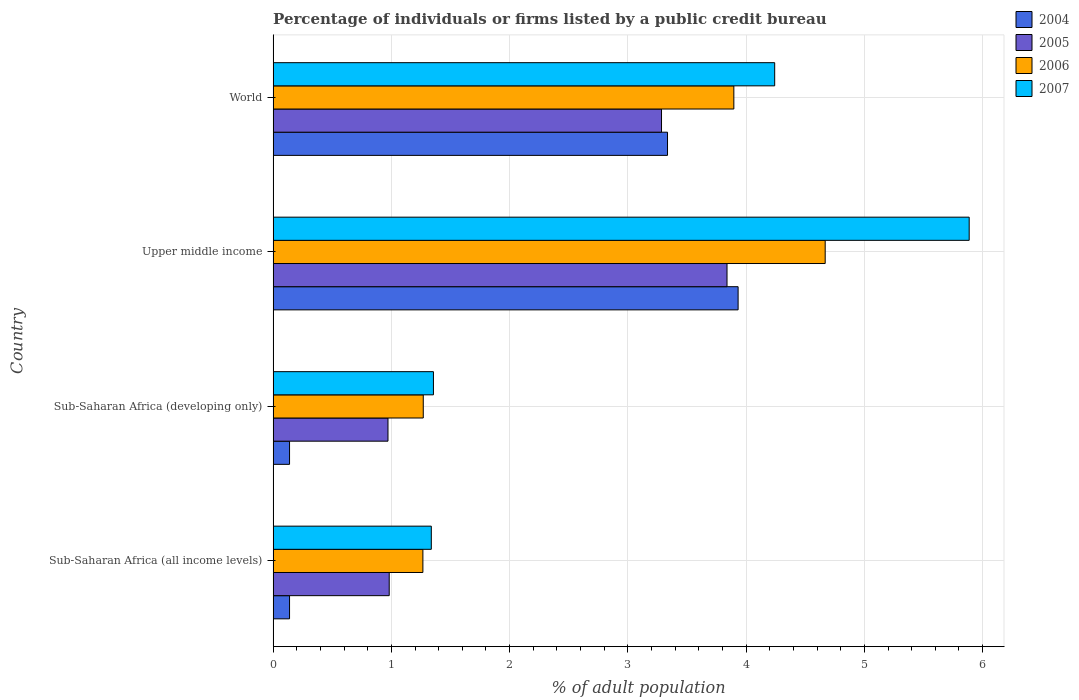How many groups of bars are there?
Provide a short and direct response. 4. Are the number of bars on each tick of the Y-axis equal?
Give a very brief answer. Yes. How many bars are there on the 3rd tick from the top?
Make the answer very short. 4. How many bars are there on the 1st tick from the bottom?
Offer a terse response. 4. What is the label of the 3rd group of bars from the top?
Provide a short and direct response. Sub-Saharan Africa (developing only). In how many cases, is the number of bars for a given country not equal to the number of legend labels?
Offer a terse response. 0. What is the percentage of population listed by a public credit bureau in 2004 in Sub-Saharan Africa (all income levels)?
Your answer should be very brief. 0.14. Across all countries, what is the maximum percentage of population listed by a public credit bureau in 2005?
Your answer should be compact. 3.84. Across all countries, what is the minimum percentage of population listed by a public credit bureau in 2005?
Your response must be concise. 0.97. In which country was the percentage of population listed by a public credit bureau in 2007 maximum?
Provide a short and direct response. Upper middle income. In which country was the percentage of population listed by a public credit bureau in 2007 minimum?
Ensure brevity in your answer.  Sub-Saharan Africa (all income levels). What is the total percentage of population listed by a public credit bureau in 2004 in the graph?
Make the answer very short. 7.55. What is the difference between the percentage of population listed by a public credit bureau in 2007 in Sub-Saharan Africa (developing only) and that in World?
Provide a short and direct response. -2.89. What is the difference between the percentage of population listed by a public credit bureau in 2005 in Sub-Saharan Africa (developing only) and the percentage of population listed by a public credit bureau in 2007 in World?
Keep it short and to the point. -3.27. What is the average percentage of population listed by a public credit bureau in 2006 per country?
Keep it short and to the point. 2.78. What is the difference between the percentage of population listed by a public credit bureau in 2004 and percentage of population listed by a public credit bureau in 2006 in Upper middle income?
Your answer should be very brief. -0.74. In how many countries, is the percentage of population listed by a public credit bureau in 2007 greater than 2.2 %?
Your answer should be very brief. 2. What is the ratio of the percentage of population listed by a public credit bureau in 2004 in Sub-Saharan Africa (all income levels) to that in Upper middle income?
Provide a short and direct response. 0.04. Is the difference between the percentage of population listed by a public credit bureau in 2004 in Sub-Saharan Africa (all income levels) and World greater than the difference between the percentage of population listed by a public credit bureau in 2006 in Sub-Saharan Africa (all income levels) and World?
Your answer should be very brief. No. What is the difference between the highest and the second highest percentage of population listed by a public credit bureau in 2007?
Make the answer very short. 1.64. What is the difference between the highest and the lowest percentage of population listed by a public credit bureau in 2005?
Provide a succinct answer. 2.87. In how many countries, is the percentage of population listed by a public credit bureau in 2006 greater than the average percentage of population listed by a public credit bureau in 2006 taken over all countries?
Your answer should be compact. 2. Is the sum of the percentage of population listed by a public credit bureau in 2006 in Sub-Saharan Africa (all income levels) and Sub-Saharan Africa (developing only) greater than the maximum percentage of population listed by a public credit bureau in 2004 across all countries?
Provide a succinct answer. No. What does the 1st bar from the top in Sub-Saharan Africa (developing only) represents?
Provide a short and direct response. 2007. What does the 4th bar from the bottom in World represents?
Your answer should be compact. 2007. Is it the case that in every country, the sum of the percentage of population listed by a public credit bureau in 2004 and percentage of population listed by a public credit bureau in 2006 is greater than the percentage of population listed by a public credit bureau in 2007?
Make the answer very short. Yes. Are all the bars in the graph horizontal?
Give a very brief answer. Yes. What is the difference between two consecutive major ticks on the X-axis?
Your response must be concise. 1. Are the values on the major ticks of X-axis written in scientific E-notation?
Offer a terse response. No. Does the graph contain any zero values?
Make the answer very short. No. Does the graph contain grids?
Offer a very short reply. Yes. Where does the legend appear in the graph?
Make the answer very short. Top right. What is the title of the graph?
Your answer should be very brief. Percentage of individuals or firms listed by a public credit bureau. Does "2006" appear as one of the legend labels in the graph?
Your response must be concise. Yes. What is the label or title of the X-axis?
Your answer should be compact. % of adult population. What is the label or title of the Y-axis?
Provide a succinct answer. Country. What is the % of adult population in 2004 in Sub-Saharan Africa (all income levels)?
Your answer should be compact. 0.14. What is the % of adult population in 2005 in Sub-Saharan Africa (all income levels)?
Your answer should be very brief. 0.98. What is the % of adult population in 2006 in Sub-Saharan Africa (all income levels)?
Your answer should be very brief. 1.27. What is the % of adult population of 2007 in Sub-Saharan Africa (all income levels)?
Keep it short and to the point. 1.34. What is the % of adult population of 2004 in Sub-Saharan Africa (developing only)?
Offer a very short reply. 0.14. What is the % of adult population in 2005 in Sub-Saharan Africa (developing only)?
Give a very brief answer. 0.97. What is the % of adult population of 2006 in Sub-Saharan Africa (developing only)?
Your answer should be compact. 1.27. What is the % of adult population of 2007 in Sub-Saharan Africa (developing only)?
Your answer should be compact. 1.36. What is the % of adult population in 2004 in Upper middle income?
Your response must be concise. 3.93. What is the % of adult population in 2005 in Upper middle income?
Offer a very short reply. 3.84. What is the % of adult population of 2006 in Upper middle income?
Your answer should be very brief. 4.67. What is the % of adult population of 2007 in Upper middle income?
Provide a short and direct response. 5.89. What is the % of adult population in 2004 in World?
Give a very brief answer. 3.34. What is the % of adult population in 2005 in World?
Offer a very short reply. 3.28. What is the % of adult population of 2006 in World?
Offer a terse response. 3.9. What is the % of adult population in 2007 in World?
Your answer should be compact. 4.24. Across all countries, what is the maximum % of adult population in 2004?
Give a very brief answer. 3.93. Across all countries, what is the maximum % of adult population of 2005?
Provide a short and direct response. 3.84. Across all countries, what is the maximum % of adult population of 2006?
Offer a very short reply. 4.67. Across all countries, what is the maximum % of adult population of 2007?
Offer a very short reply. 5.89. Across all countries, what is the minimum % of adult population of 2004?
Offer a terse response. 0.14. Across all countries, what is the minimum % of adult population in 2005?
Your response must be concise. 0.97. Across all countries, what is the minimum % of adult population of 2006?
Provide a short and direct response. 1.27. Across all countries, what is the minimum % of adult population in 2007?
Provide a short and direct response. 1.34. What is the total % of adult population of 2004 in the graph?
Your response must be concise. 7.55. What is the total % of adult population of 2005 in the graph?
Provide a short and direct response. 9.08. What is the total % of adult population of 2006 in the graph?
Ensure brevity in your answer.  11.1. What is the total % of adult population of 2007 in the graph?
Your answer should be compact. 12.82. What is the difference between the % of adult population in 2005 in Sub-Saharan Africa (all income levels) and that in Sub-Saharan Africa (developing only)?
Offer a terse response. 0.01. What is the difference between the % of adult population of 2006 in Sub-Saharan Africa (all income levels) and that in Sub-Saharan Africa (developing only)?
Make the answer very short. -0. What is the difference between the % of adult population of 2007 in Sub-Saharan Africa (all income levels) and that in Sub-Saharan Africa (developing only)?
Offer a terse response. -0.02. What is the difference between the % of adult population of 2004 in Sub-Saharan Africa (all income levels) and that in Upper middle income?
Make the answer very short. -3.79. What is the difference between the % of adult population in 2005 in Sub-Saharan Africa (all income levels) and that in Upper middle income?
Offer a terse response. -2.86. What is the difference between the % of adult population in 2006 in Sub-Saharan Africa (all income levels) and that in Upper middle income?
Ensure brevity in your answer.  -3.4. What is the difference between the % of adult population in 2007 in Sub-Saharan Africa (all income levels) and that in Upper middle income?
Your answer should be compact. -4.55. What is the difference between the % of adult population in 2004 in Sub-Saharan Africa (all income levels) and that in World?
Your answer should be compact. -3.2. What is the difference between the % of adult population in 2005 in Sub-Saharan Africa (all income levels) and that in World?
Offer a terse response. -2.3. What is the difference between the % of adult population of 2006 in Sub-Saharan Africa (all income levels) and that in World?
Keep it short and to the point. -2.63. What is the difference between the % of adult population in 2007 in Sub-Saharan Africa (all income levels) and that in World?
Keep it short and to the point. -2.9. What is the difference between the % of adult population in 2004 in Sub-Saharan Africa (developing only) and that in Upper middle income?
Offer a terse response. -3.79. What is the difference between the % of adult population of 2005 in Sub-Saharan Africa (developing only) and that in Upper middle income?
Your response must be concise. -2.87. What is the difference between the % of adult population in 2006 in Sub-Saharan Africa (developing only) and that in Upper middle income?
Give a very brief answer. -3.4. What is the difference between the % of adult population in 2007 in Sub-Saharan Africa (developing only) and that in Upper middle income?
Offer a terse response. -4.53. What is the difference between the % of adult population of 2004 in Sub-Saharan Africa (developing only) and that in World?
Offer a terse response. -3.2. What is the difference between the % of adult population of 2005 in Sub-Saharan Africa (developing only) and that in World?
Your response must be concise. -2.31. What is the difference between the % of adult population in 2006 in Sub-Saharan Africa (developing only) and that in World?
Keep it short and to the point. -2.63. What is the difference between the % of adult population in 2007 in Sub-Saharan Africa (developing only) and that in World?
Make the answer very short. -2.89. What is the difference between the % of adult population of 2004 in Upper middle income and that in World?
Provide a succinct answer. 0.6. What is the difference between the % of adult population of 2005 in Upper middle income and that in World?
Keep it short and to the point. 0.55. What is the difference between the % of adult population in 2006 in Upper middle income and that in World?
Offer a terse response. 0.77. What is the difference between the % of adult population of 2007 in Upper middle income and that in World?
Offer a terse response. 1.64. What is the difference between the % of adult population of 2004 in Sub-Saharan Africa (all income levels) and the % of adult population of 2005 in Sub-Saharan Africa (developing only)?
Provide a succinct answer. -0.83. What is the difference between the % of adult population of 2004 in Sub-Saharan Africa (all income levels) and the % of adult population of 2006 in Sub-Saharan Africa (developing only)?
Offer a very short reply. -1.13. What is the difference between the % of adult population of 2004 in Sub-Saharan Africa (all income levels) and the % of adult population of 2007 in Sub-Saharan Africa (developing only)?
Ensure brevity in your answer.  -1.22. What is the difference between the % of adult population of 2005 in Sub-Saharan Africa (all income levels) and the % of adult population of 2006 in Sub-Saharan Africa (developing only)?
Your answer should be very brief. -0.29. What is the difference between the % of adult population in 2005 in Sub-Saharan Africa (all income levels) and the % of adult population in 2007 in Sub-Saharan Africa (developing only)?
Keep it short and to the point. -0.37. What is the difference between the % of adult population of 2006 in Sub-Saharan Africa (all income levels) and the % of adult population of 2007 in Sub-Saharan Africa (developing only)?
Ensure brevity in your answer.  -0.09. What is the difference between the % of adult population in 2004 in Sub-Saharan Africa (all income levels) and the % of adult population in 2005 in Upper middle income?
Make the answer very short. -3.7. What is the difference between the % of adult population of 2004 in Sub-Saharan Africa (all income levels) and the % of adult population of 2006 in Upper middle income?
Make the answer very short. -4.53. What is the difference between the % of adult population in 2004 in Sub-Saharan Africa (all income levels) and the % of adult population in 2007 in Upper middle income?
Offer a terse response. -5.75. What is the difference between the % of adult population in 2005 in Sub-Saharan Africa (all income levels) and the % of adult population in 2006 in Upper middle income?
Your answer should be very brief. -3.69. What is the difference between the % of adult population in 2005 in Sub-Saharan Africa (all income levels) and the % of adult population in 2007 in Upper middle income?
Your response must be concise. -4.9. What is the difference between the % of adult population of 2006 in Sub-Saharan Africa (all income levels) and the % of adult population of 2007 in Upper middle income?
Ensure brevity in your answer.  -4.62. What is the difference between the % of adult population of 2004 in Sub-Saharan Africa (all income levels) and the % of adult population of 2005 in World?
Ensure brevity in your answer.  -3.15. What is the difference between the % of adult population in 2004 in Sub-Saharan Africa (all income levels) and the % of adult population in 2006 in World?
Make the answer very short. -3.76. What is the difference between the % of adult population in 2004 in Sub-Saharan Africa (all income levels) and the % of adult population in 2007 in World?
Your answer should be compact. -4.1. What is the difference between the % of adult population of 2005 in Sub-Saharan Africa (all income levels) and the % of adult population of 2006 in World?
Your response must be concise. -2.91. What is the difference between the % of adult population of 2005 in Sub-Saharan Africa (all income levels) and the % of adult population of 2007 in World?
Offer a very short reply. -3.26. What is the difference between the % of adult population in 2006 in Sub-Saharan Africa (all income levels) and the % of adult population in 2007 in World?
Give a very brief answer. -2.98. What is the difference between the % of adult population of 2004 in Sub-Saharan Africa (developing only) and the % of adult population of 2005 in Upper middle income?
Your answer should be compact. -3.7. What is the difference between the % of adult population in 2004 in Sub-Saharan Africa (developing only) and the % of adult population in 2006 in Upper middle income?
Your answer should be compact. -4.53. What is the difference between the % of adult population in 2004 in Sub-Saharan Africa (developing only) and the % of adult population in 2007 in Upper middle income?
Provide a succinct answer. -5.75. What is the difference between the % of adult population of 2005 in Sub-Saharan Africa (developing only) and the % of adult population of 2006 in Upper middle income?
Offer a terse response. -3.7. What is the difference between the % of adult population in 2005 in Sub-Saharan Africa (developing only) and the % of adult population in 2007 in Upper middle income?
Offer a very short reply. -4.92. What is the difference between the % of adult population in 2006 in Sub-Saharan Africa (developing only) and the % of adult population in 2007 in Upper middle income?
Offer a very short reply. -4.62. What is the difference between the % of adult population in 2004 in Sub-Saharan Africa (developing only) and the % of adult population in 2005 in World?
Your answer should be compact. -3.15. What is the difference between the % of adult population of 2004 in Sub-Saharan Africa (developing only) and the % of adult population of 2006 in World?
Your answer should be compact. -3.76. What is the difference between the % of adult population in 2004 in Sub-Saharan Africa (developing only) and the % of adult population in 2007 in World?
Your answer should be compact. -4.1. What is the difference between the % of adult population in 2005 in Sub-Saharan Africa (developing only) and the % of adult population in 2006 in World?
Make the answer very short. -2.92. What is the difference between the % of adult population of 2005 in Sub-Saharan Africa (developing only) and the % of adult population of 2007 in World?
Offer a very short reply. -3.27. What is the difference between the % of adult population of 2006 in Sub-Saharan Africa (developing only) and the % of adult population of 2007 in World?
Offer a terse response. -2.97. What is the difference between the % of adult population in 2004 in Upper middle income and the % of adult population in 2005 in World?
Offer a very short reply. 0.65. What is the difference between the % of adult population in 2004 in Upper middle income and the % of adult population in 2006 in World?
Provide a succinct answer. 0.04. What is the difference between the % of adult population in 2004 in Upper middle income and the % of adult population in 2007 in World?
Provide a succinct answer. -0.31. What is the difference between the % of adult population of 2005 in Upper middle income and the % of adult population of 2006 in World?
Provide a succinct answer. -0.06. What is the difference between the % of adult population in 2005 in Upper middle income and the % of adult population in 2007 in World?
Offer a terse response. -0.4. What is the difference between the % of adult population in 2006 in Upper middle income and the % of adult population in 2007 in World?
Your answer should be very brief. 0.43. What is the average % of adult population in 2004 per country?
Give a very brief answer. 1.89. What is the average % of adult population of 2005 per country?
Offer a terse response. 2.27. What is the average % of adult population of 2006 per country?
Your answer should be very brief. 2.78. What is the average % of adult population in 2007 per country?
Keep it short and to the point. 3.21. What is the difference between the % of adult population of 2004 and % of adult population of 2005 in Sub-Saharan Africa (all income levels)?
Your answer should be compact. -0.84. What is the difference between the % of adult population of 2004 and % of adult population of 2006 in Sub-Saharan Africa (all income levels)?
Make the answer very short. -1.13. What is the difference between the % of adult population of 2004 and % of adult population of 2007 in Sub-Saharan Africa (all income levels)?
Your answer should be compact. -1.2. What is the difference between the % of adult population of 2005 and % of adult population of 2006 in Sub-Saharan Africa (all income levels)?
Ensure brevity in your answer.  -0.28. What is the difference between the % of adult population in 2005 and % of adult population in 2007 in Sub-Saharan Africa (all income levels)?
Your response must be concise. -0.36. What is the difference between the % of adult population in 2006 and % of adult population in 2007 in Sub-Saharan Africa (all income levels)?
Provide a succinct answer. -0.07. What is the difference between the % of adult population of 2004 and % of adult population of 2005 in Sub-Saharan Africa (developing only)?
Provide a short and direct response. -0.83. What is the difference between the % of adult population of 2004 and % of adult population of 2006 in Sub-Saharan Africa (developing only)?
Provide a short and direct response. -1.13. What is the difference between the % of adult population in 2004 and % of adult population in 2007 in Sub-Saharan Africa (developing only)?
Your answer should be compact. -1.22. What is the difference between the % of adult population of 2005 and % of adult population of 2006 in Sub-Saharan Africa (developing only)?
Your response must be concise. -0.3. What is the difference between the % of adult population in 2005 and % of adult population in 2007 in Sub-Saharan Africa (developing only)?
Your answer should be compact. -0.38. What is the difference between the % of adult population of 2006 and % of adult population of 2007 in Sub-Saharan Africa (developing only)?
Your answer should be compact. -0.09. What is the difference between the % of adult population of 2004 and % of adult population of 2005 in Upper middle income?
Ensure brevity in your answer.  0.09. What is the difference between the % of adult population in 2004 and % of adult population in 2006 in Upper middle income?
Your answer should be compact. -0.74. What is the difference between the % of adult population of 2004 and % of adult population of 2007 in Upper middle income?
Your answer should be compact. -1.95. What is the difference between the % of adult population in 2005 and % of adult population in 2006 in Upper middle income?
Make the answer very short. -0.83. What is the difference between the % of adult population in 2005 and % of adult population in 2007 in Upper middle income?
Keep it short and to the point. -2.05. What is the difference between the % of adult population in 2006 and % of adult population in 2007 in Upper middle income?
Ensure brevity in your answer.  -1.22. What is the difference between the % of adult population in 2004 and % of adult population in 2005 in World?
Make the answer very short. 0.05. What is the difference between the % of adult population in 2004 and % of adult population in 2006 in World?
Provide a succinct answer. -0.56. What is the difference between the % of adult population of 2004 and % of adult population of 2007 in World?
Provide a succinct answer. -0.91. What is the difference between the % of adult population in 2005 and % of adult population in 2006 in World?
Give a very brief answer. -0.61. What is the difference between the % of adult population of 2005 and % of adult population of 2007 in World?
Your response must be concise. -0.96. What is the difference between the % of adult population in 2006 and % of adult population in 2007 in World?
Your answer should be very brief. -0.35. What is the ratio of the % of adult population in 2005 in Sub-Saharan Africa (all income levels) to that in Sub-Saharan Africa (developing only)?
Make the answer very short. 1.01. What is the ratio of the % of adult population in 2006 in Sub-Saharan Africa (all income levels) to that in Sub-Saharan Africa (developing only)?
Ensure brevity in your answer.  1. What is the ratio of the % of adult population of 2007 in Sub-Saharan Africa (all income levels) to that in Sub-Saharan Africa (developing only)?
Provide a short and direct response. 0.99. What is the ratio of the % of adult population of 2004 in Sub-Saharan Africa (all income levels) to that in Upper middle income?
Ensure brevity in your answer.  0.04. What is the ratio of the % of adult population of 2005 in Sub-Saharan Africa (all income levels) to that in Upper middle income?
Your answer should be compact. 0.26. What is the ratio of the % of adult population of 2006 in Sub-Saharan Africa (all income levels) to that in Upper middle income?
Make the answer very short. 0.27. What is the ratio of the % of adult population of 2007 in Sub-Saharan Africa (all income levels) to that in Upper middle income?
Provide a short and direct response. 0.23. What is the ratio of the % of adult population in 2004 in Sub-Saharan Africa (all income levels) to that in World?
Offer a very short reply. 0.04. What is the ratio of the % of adult population in 2005 in Sub-Saharan Africa (all income levels) to that in World?
Your answer should be compact. 0.3. What is the ratio of the % of adult population in 2006 in Sub-Saharan Africa (all income levels) to that in World?
Provide a short and direct response. 0.33. What is the ratio of the % of adult population of 2007 in Sub-Saharan Africa (all income levels) to that in World?
Give a very brief answer. 0.32. What is the ratio of the % of adult population of 2004 in Sub-Saharan Africa (developing only) to that in Upper middle income?
Ensure brevity in your answer.  0.04. What is the ratio of the % of adult population in 2005 in Sub-Saharan Africa (developing only) to that in Upper middle income?
Your answer should be very brief. 0.25. What is the ratio of the % of adult population of 2006 in Sub-Saharan Africa (developing only) to that in Upper middle income?
Provide a succinct answer. 0.27. What is the ratio of the % of adult population in 2007 in Sub-Saharan Africa (developing only) to that in Upper middle income?
Your answer should be very brief. 0.23. What is the ratio of the % of adult population of 2004 in Sub-Saharan Africa (developing only) to that in World?
Your response must be concise. 0.04. What is the ratio of the % of adult population in 2005 in Sub-Saharan Africa (developing only) to that in World?
Ensure brevity in your answer.  0.3. What is the ratio of the % of adult population of 2006 in Sub-Saharan Africa (developing only) to that in World?
Keep it short and to the point. 0.33. What is the ratio of the % of adult population of 2007 in Sub-Saharan Africa (developing only) to that in World?
Ensure brevity in your answer.  0.32. What is the ratio of the % of adult population in 2004 in Upper middle income to that in World?
Your answer should be compact. 1.18. What is the ratio of the % of adult population in 2005 in Upper middle income to that in World?
Give a very brief answer. 1.17. What is the ratio of the % of adult population in 2006 in Upper middle income to that in World?
Offer a very short reply. 1.2. What is the ratio of the % of adult population of 2007 in Upper middle income to that in World?
Your answer should be compact. 1.39. What is the difference between the highest and the second highest % of adult population in 2004?
Your answer should be very brief. 0.6. What is the difference between the highest and the second highest % of adult population of 2005?
Provide a short and direct response. 0.55. What is the difference between the highest and the second highest % of adult population in 2006?
Your answer should be compact. 0.77. What is the difference between the highest and the second highest % of adult population in 2007?
Give a very brief answer. 1.64. What is the difference between the highest and the lowest % of adult population of 2004?
Give a very brief answer. 3.79. What is the difference between the highest and the lowest % of adult population in 2005?
Your answer should be very brief. 2.87. What is the difference between the highest and the lowest % of adult population of 2006?
Keep it short and to the point. 3.4. What is the difference between the highest and the lowest % of adult population in 2007?
Provide a succinct answer. 4.55. 